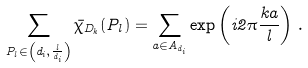<formula> <loc_0><loc_0><loc_500><loc_500>\sum _ { P _ { l } \in \left ( d _ { i } , \frac { l } { d _ { i } } \right ) } \bar { \chi } _ { D _ { k } } ( P _ { l } ) = \sum _ { a \in A _ { d _ { i } } } \exp \left ( i 2 \pi \frac { k a } { l } \right ) \, .</formula> 